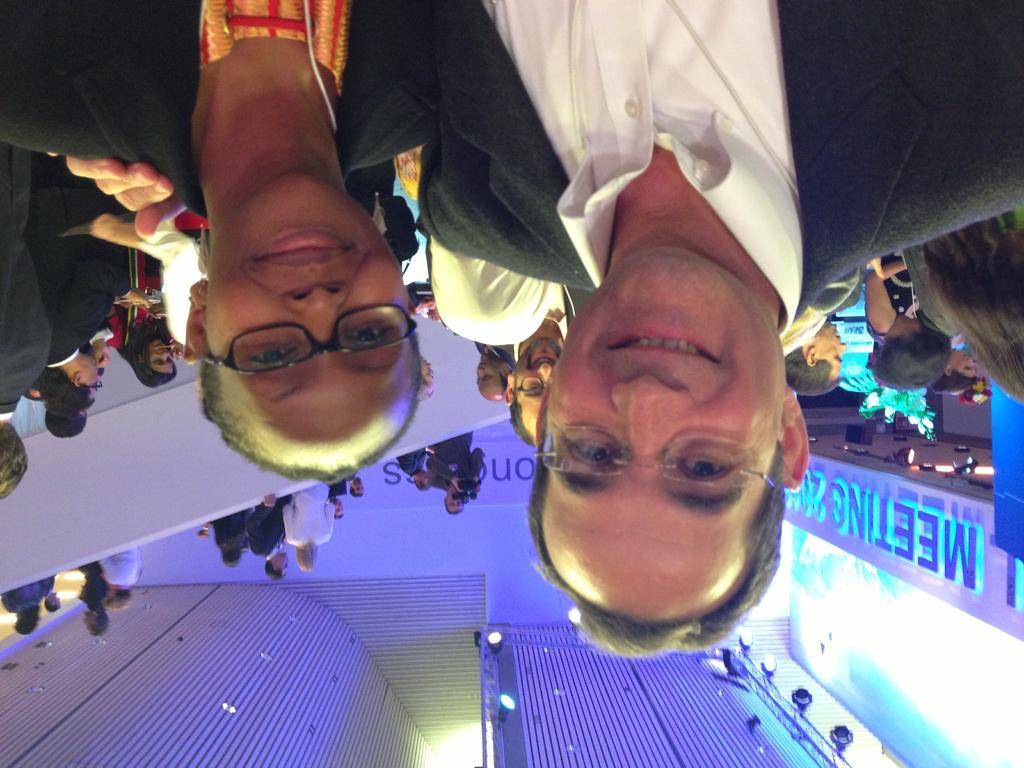How would you summarize this image in a sentence or two? In this picture we can see two people wore spectacles, smiling and at the back of them we can see a group of people, lights and some objects. 